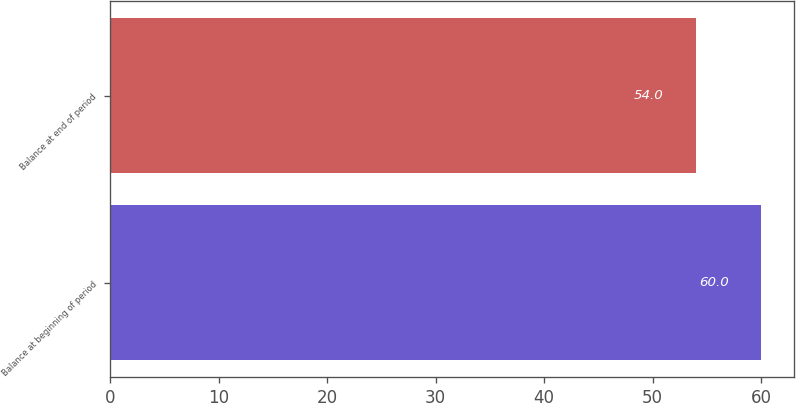Convert chart. <chart><loc_0><loc_0><loc_500><loc_500><bar_chart><fcel>Balance at beginning of period<fcel>Balance at end of period<nl><fcel>60<fcel>54<nl></chart> 